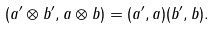<formula> <loc_0><loc_0><loc_500><loc_500>( a ^ { \prime } \otimes b ^ { \prime } , a \otimes b ) = ( a ^ { \prime } , a ) ( b ^ { \prime } , b ) .</formula> 